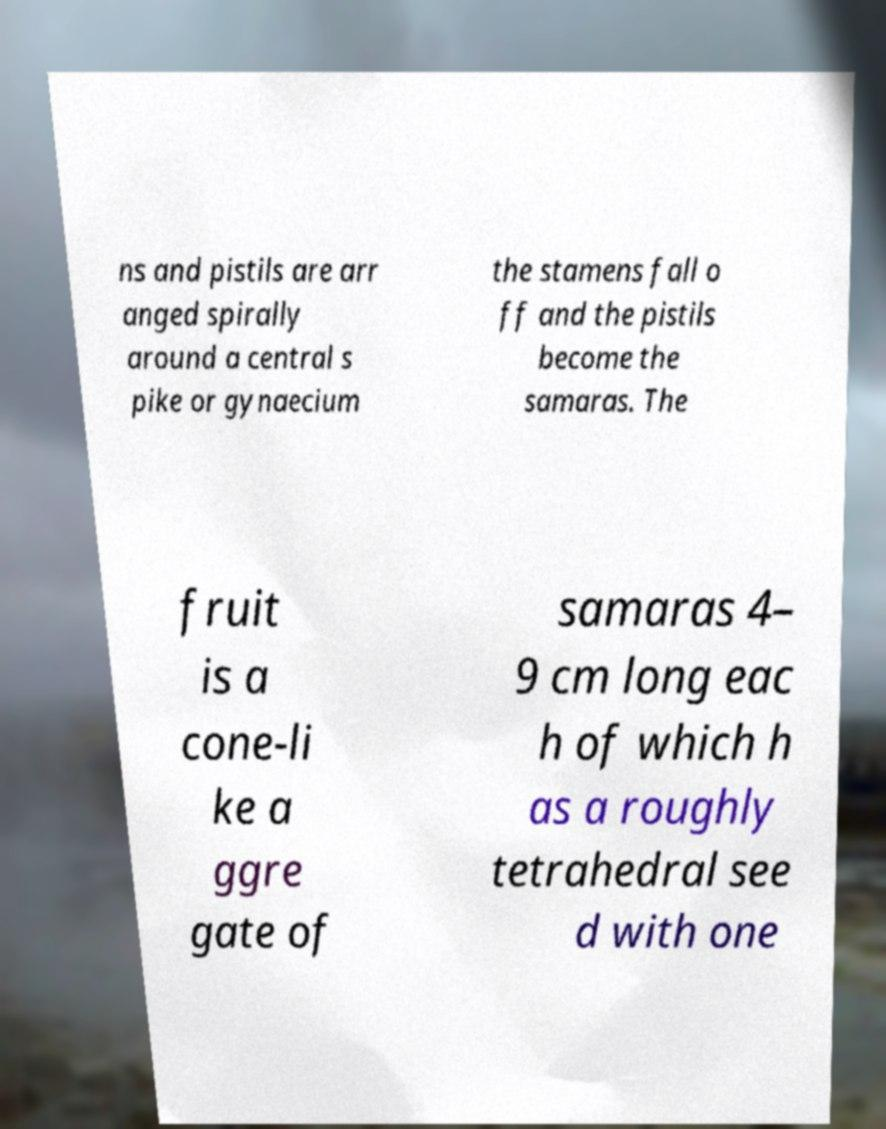There's text embedded in this image that I need extracted. Can you transcribe it verbatim? ns and pistils are arr anged spirally around a central s pike or gynaecium the stamens fall o ff and the pistils become the samaras. The fruit is a cone-li ke a ggre gate of samaras 4– 9 cm long eac h of which h as a roughly tetrahedral see d with one 